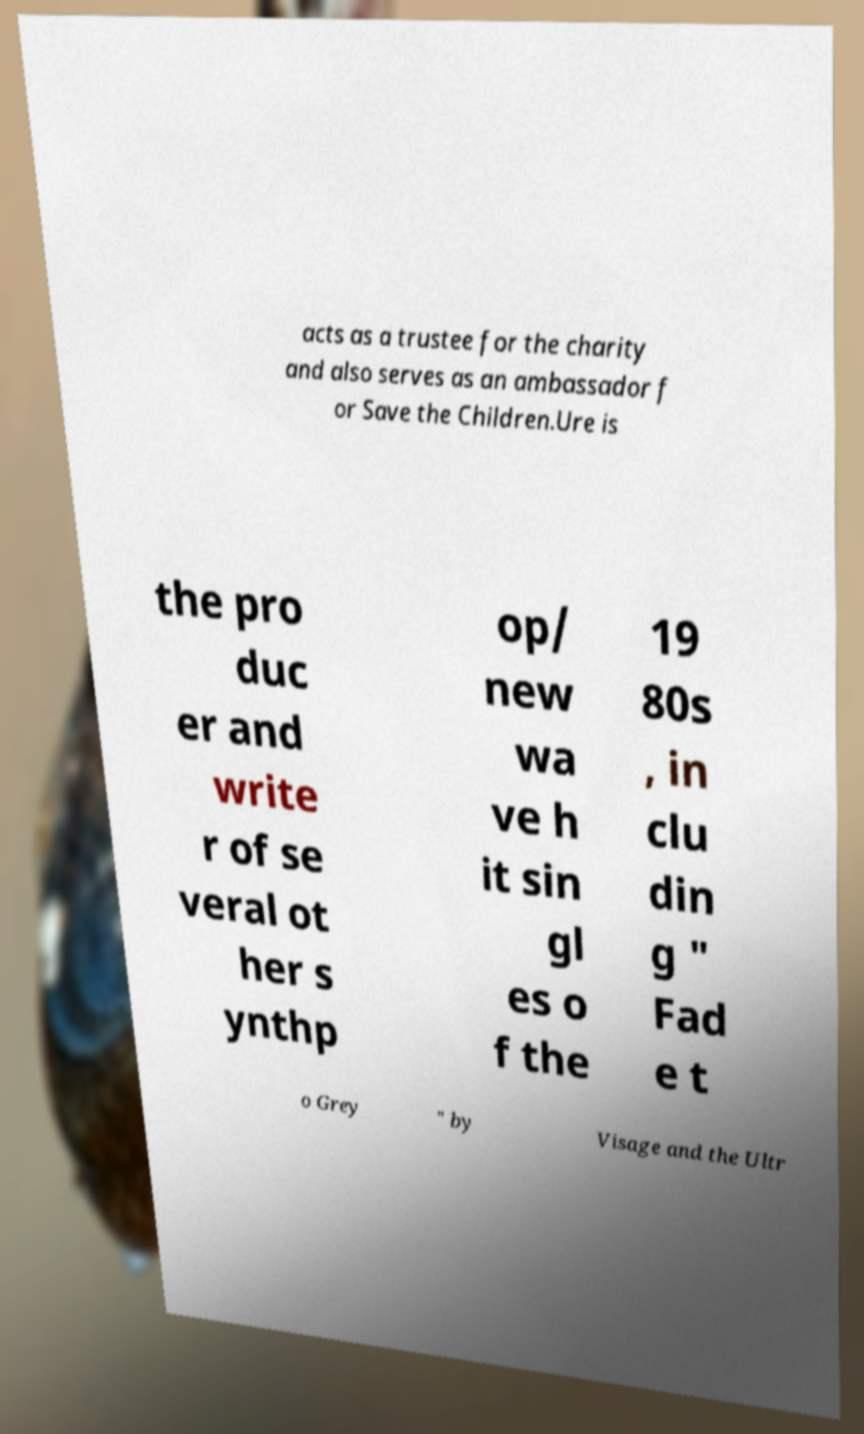There's text embedded in this image that I need extracted. Can you transcribe it verbatim? acts as a trustee for the charity and also serves as an ambassador f or Save the Children.Ure is the pro duc er and write r of se veral ot her s ynthp op/ new wa ve h it sin gl es o f the 19 80s , in clu din g " Fad e t o Grey " by Visage and the Ultr 